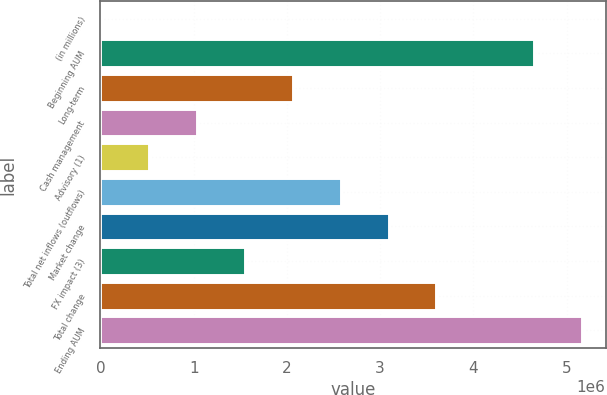Convert chart. <chart><loc_0><loc_0><loc_500><loc_500><bar_chart><fcel>(in millions)<fcel>Beginning AUM<fcel>Long-term<fcel>Cash management<fcel>Advisory (1)<fcel>Total net inflows (outflows)<fcel>Market change<fcel>FX impact (3)<fcel>Total change<fcel>Ending AUM<nl><fcel>2016<fcel>4.64541e+06<fcel>2.06035e+06<fcel>1.03118e+06<fcel>516600<fcel>2.57493e+06<fcel>3.08952e+06<fcel>1.54577e+06<fcel>3.6041e+06<fcel>5.16e+06<nl></chart> 